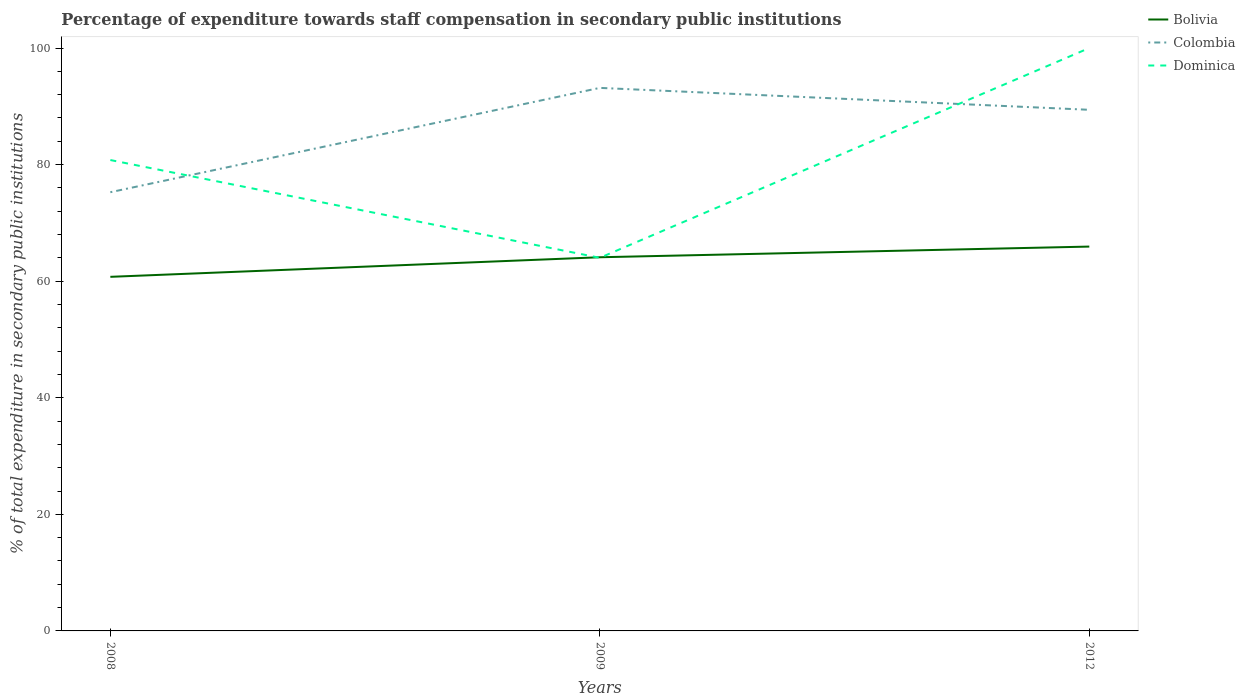How many different coloured lines are there?
Offer a very short reply. 3. Across all years, what is the maximum percentage of expenditure towards staff compensation in Colombia?
Offer a very short reply. 75.26. What is the total percentage of expenditure towards staff compensation in Colombia in the graph?
Offer a terse response. -17.9. What is the difference between the highest and the second highest percentage of expenditure towards staff compensation in Colombia?
Offer a terse response. 17.9. What is the difference between the highest and the lowest percentage of expenditure towards staff compensation in Dominica?
Provide a short and direct response. 1. What is the difference between two consecutive major ticks on the Y-axis?
Provide a short and direct response. 20. Does the graph contain any zero values?
Provide a short and direct response. No. What is the title of the graph?
Make the answer very short. Percentage of expenditure towards staff compensation in secondary public institutions. What is the label or title of the X-axis?
Your answer should be very brief. Years. What is the label or title of the Y-axis?
Make the answer very short. % of total expenditure in secondary public institutions. What is the % of total expenditure in secondary public institutions in Bolivia in 2008?
Ensure brevity in your answer.  60.75. What is the % of total expenditure in secondary public institutions in Colombia in 2008?
Give a very brief answer. 75.26. What is the % of total expenditure in secondary public institutions of Dominica in 2008?
Your answer should be compact. 80.78. What is the % of total expenditure in secondary public institutions of Bolivia in 2009?
Your answer should be compact. 64.11. What is the % of total expenditure in secondary public institutions of Colombia in 2009?
Provide a short and direct response. 93.16. What is the % of total expenditure in secondary public institutions of Dominica in 2009?
Your response must be concise. 64.01. What is the % of total expenditure in secondary public institutions in Bolivia in 2012?
Keep it short and to the point. 65.94. What is the % of total expenditure in secondary public institutions of Colombia in 2012?
Offer a very short reply. 89.4. Across all years, what is the maximum % of total expenditure in secondary public institutions in Bolivia?
Your answer should be compact. 65.94. Across all years, what is the maximum % of total expenditure in secondary public institutions in Colombia?
Your answer should be very brief. 93.16. Across all years, what is the minimum % of total expenditure in secondary public institutions in Bolivia?
Ensure brevity in your answer.  60.75. Across all years, what is the minimum % of total expenditure in secondary public institutions of Colombia?
Provide a short and direct response. 75.26. Across all years, what is the minimum % of total expenditure in secondary public institutions in Dominica?
Offer a terse response. 64.01. What is the total % of total expenditure in secondary public institutions in Bolivia in the graph?
Provide a succinct answer. 190.79. What is the total % of total expenditure in secondary public institutions in Colombia in the graph?
Make the answer very short. 257.82. What is the total % of total expenditure in secondary public institutions of Dominica in the graph?
Provide a succinct answer. 244.79. What is the difference between the % of total expenditure in secondary public institutions in Bolivia in 2008 and that in 2009?
Your answer should be very brief. -3.36. What is the difference between the % of total expenditure in secondary public institutions of Colombia in 2008 and that in 2009?
Offer a very short reply. -17.9. What is the difference between the % of total expenditure in secondary public institutions of Dominica in 2008 and that in 2009?
Your answer should be compact. 16.78. What is the difference between the % of total expenditure in secondary public institutions in Bolivia in 2008 and that in 2012?
Offer a terse response. -5.19. What is the difference between the % of total expenditure in secondary public institutions in Colombia in 2008 and that in 2012?
Your answer should be compact. -14.14. What is the difference between the % of total expenditure in secondary public institutions in Dominica in 2008 and that in 2012?
Your response must be concise. -19.22. What is the difference between the % of total expenditure in secondary public institutions in Bolivia in 2009 and that in 2012?
Your response must be concise. -1.83. What is the difference between the % of total expenditure in secondary public institutions in Colombia in 2009 and that in 2012?
Your answer should be compact. 3.76. What is the difference between the % of total expenditure in secondary public institutions of Dominica in 2009 and that in 2012?
Provide a succinct answer. -35.99. What is the difference between the % of total expenditure in secondary public institutions in Bolivia in 2008 and the % of total expenditure in secondary public institutions in Colombia in 2009?
Your answer should be very brief. -32.41. What is the difference between the % of total expenditure in secondary public institutions in Bolivia in 2008 and the % of total expenditure in secondary public institutions in Dominica in 2009?
Your answer should be compact. -3.26. What is the difference between the % of total expenditure in secondary public institutions of Colombia in 2008 and the % of total expenditure in secondary public institutions of Dominica in 2009?
Provide a short and direct response. 11.26. What is the difference between the % of total expenditure in secondary public institutions of Bolivia in 2008 and the % of total expenditure in secondary public institutions of Colombia in 2012?
Your response must be concise. -28.65. What is the difference between the % of total expenditure in secondary public institutions in Bolivia in 2008 and the % of total expenditure in secondary public institutions in Dominica in 2012?
Offer a very short reply. -39.25. What is the difference between the % of total expenditure in secondary public institutions in Colombia in 2008 and the % of total expenditure in secondary public institutions in Dominica in 2012?
Provide a succinct answer. -24.74. What is the difference between the % of total expenditure in secondary public institutions of Bolivia in 2009 and the % of total expenditure in secondary public institutions of Colombia in 2012?
Ensure brevity in your answer.  -25.29. What is the difference between the % of total expenditure in secondary public institutions in Bolivia in 2009 and the % of total expenditure in secondary public institutions in Dominica in 2012?
Give a very brief answer. -35.89. What is the difference between the % of total expenditure in secondary public institutions in Colombia in 2009 and the % of total expenditure in secondary public institutions in Dominica in 2012?
Offer a very short reply. -6.84. What is the average % of total expenditure in secondary public institutions in Bolivia per year?
Keep it short and to the point. 63.6. What is the average % of total expenditure in secondary public institutions of Colombia per year?
Keep it short and to the point. 85.94. What is the average % of total expenditure in secondary public institutions of Dominica per year?
Your response must be concise. 81.6. In the year 2008, what is the difference between the % of total expenditure in secondary public institutions in Bolivia and % of total expenditure in secondary public institutions in Colombia?
Your answer should be compact. -14.52. In the year 2008, what is the difference between the % of total expenditure in secondary public institutions of Bolivia and % of total expenditure in secondary public institutions of Dominica?
Your answer should be compact. -20.04. In the year 2008, what is the difference between the % of total expenditure in secondary public institutions of Colombia and % of total expenditure in secondary public institutions of Dominica?
Your answer should be very brief. -5.52. In the year 2009, what is the difference between the % of total expenditure in secondary public institutions in Bolivia and % of total expenditure in secondary public institutions in Colombia?
Provide a short and direct response. -29.05. In the year 2009, what is the difference between the % of total expenditure in secondary public institutions of Bolivia and % of total expenditure in secondary public institutions of Dominica?
Your answer should be compact. 0.1. In the year 2009, what is the difference between the % of total expenditure in secondary public institutions in Colombia and % of total expenditure in secondary public institutions in Dominica?
Your answer should be very brief. 29.15. In the year 2012, what is the difference between the % of total expenditure in secondary public institutions in Bolivia and % of total expenditure in secondary public institutions in Colombia?
Give a very brief answer. -23.46. In the year 2012, what is the difference between the % of total expenditure in secondary public institutions in Bolivia and % of total expenditure in secondary public institutions in Dominica?
Provide a short and direct response. -34.06. In the year 2012, what is the difference between the % of total expenditure in secondary public institutions in Colombia and % of total expenditure in secondary public institutions in Dominica?
Offer a very short reply. -10.6. What is the ratio of the % of total expenditure in secondary public institutions of Bolivia in 2008 to that in 2009?
Make the answer very short. 0.95. What is the ratio of the % of total expenditure in secondary public institutions of Colombia in 2008 to that in 2009?
Ensure brevity in your answer.  0.81. What is the ratio of the % of total expenditure in secondary public institutions in Dominica in 2008 to that in 2009?
Ensure brevity in your answer.  1.26. What is the ratio of the % of total expenditure in secondary public institutions of Bolivia in 2008 to that in 2012?
Make the answer very short. 0.92. What is the ratio of the % of total expenditure in secondary public institutions in Colombia in 2008 to that in 2012?
Provide a short and direct response. 0.84. What is the ratio of the % of total expenditure in secondary public institutions in Dominica in 2008 to that in 2012?
Make the answer very short. 0.81. What is the ratio of the % of total expenditure in secondary public institutions in Bolivia in 2009 to that in 2012?
Provide a short and direct response. 0.97. What is the ratio of the % of total expenditure in secondary public institutions of Colombia in 2009 to that in 2012?
Make the answer very short. 1.04. What is the ratio of the % of total expenditure in secondary public institutions of Dominica in 2009 to that in 2012?
Provide a short and direct response. 0.64. What is the difference between the highest and the second highest % of total expenditure in secondary public institutions of Bolivia?
Provide a short and direct response. 1.83. What is the difference between the highest and the second highest % of total expenditure in secondary public institutions of Colombia?
Provide a succinct answer. 3.76. What is the difference between the highest and the second highest % of total expenditure in secondary public institutions of Dominica?
Provide a succinct answer. 19.22. What is the difference between the highest and the lowest % of total expenditure in secondary public institutions in Bolivia?
Your answer should be compact. 5.19. What is the difference between the highest and the lowest % of total expenditure in secondary public institutions in Colombia?
Keep it short and to the point. 17.9. What is the difference between the highest and the lowest % of total expenditure in secondary public institutions in Dominica?
Your response must be concise. 35.99. 